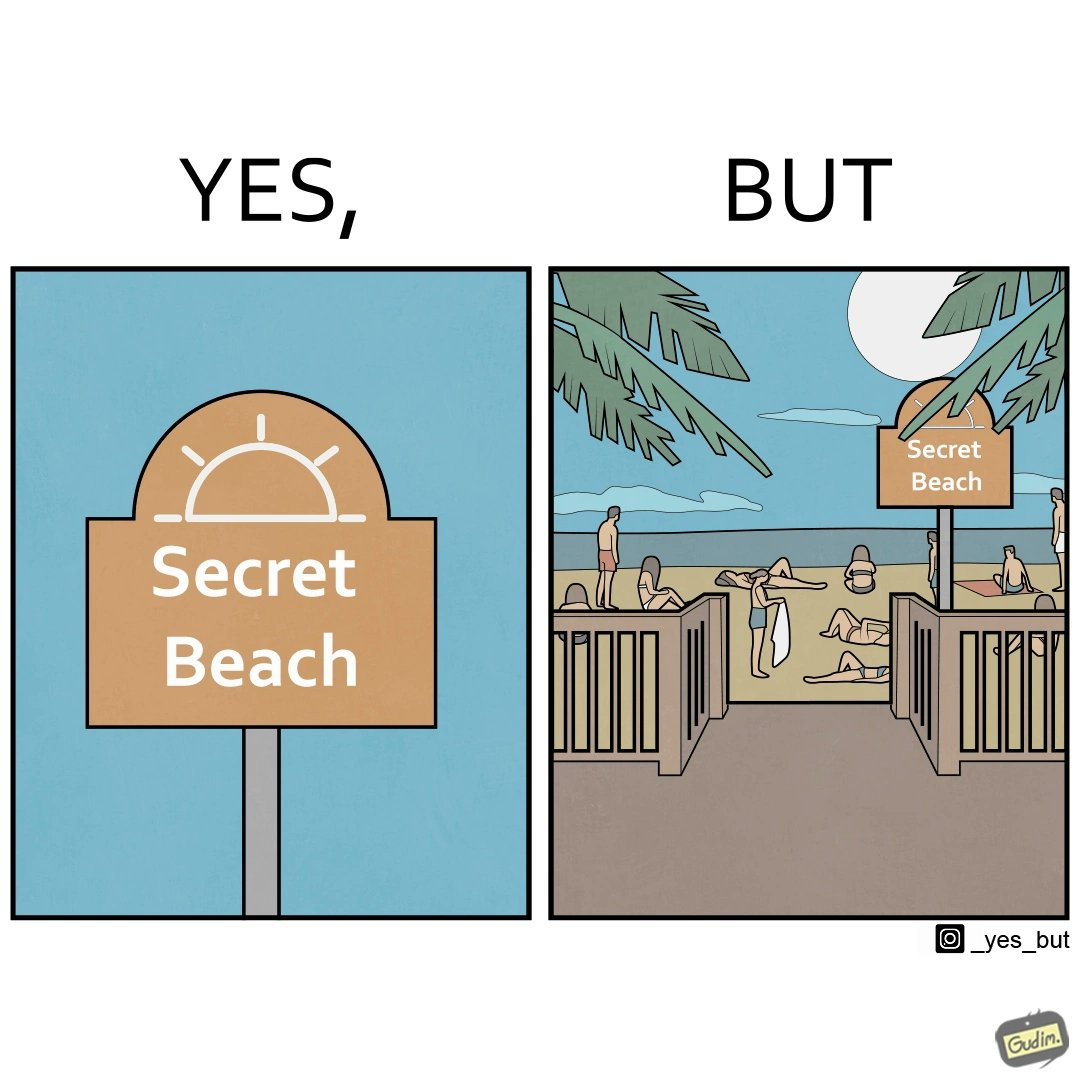What is shown in the left half versus the right half of this image? In the left part of the image: A board with "Secret Beach" written on it. In the right part of the image: People in a beach, having a board with "Secret Beach" written on it at its entrance. 